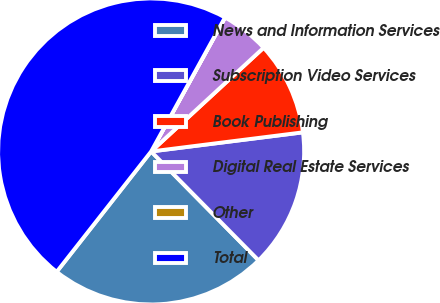Convert chart to OTSL. <chart><loc_0><loc_0><loc_500><loc_500><pie_chart><fcel>News and Information Services<fcel>Subscription Video Services<fcel>Book Publishing<fcel>Digital Real Estate Services<fcel>Other<fcel>Total<nl><fcel>22.98%<fcel>14.6%<fcel>9.86%<fcel>5.12%<fcel>0.01%<fcel>47.42%<nl></chart> 